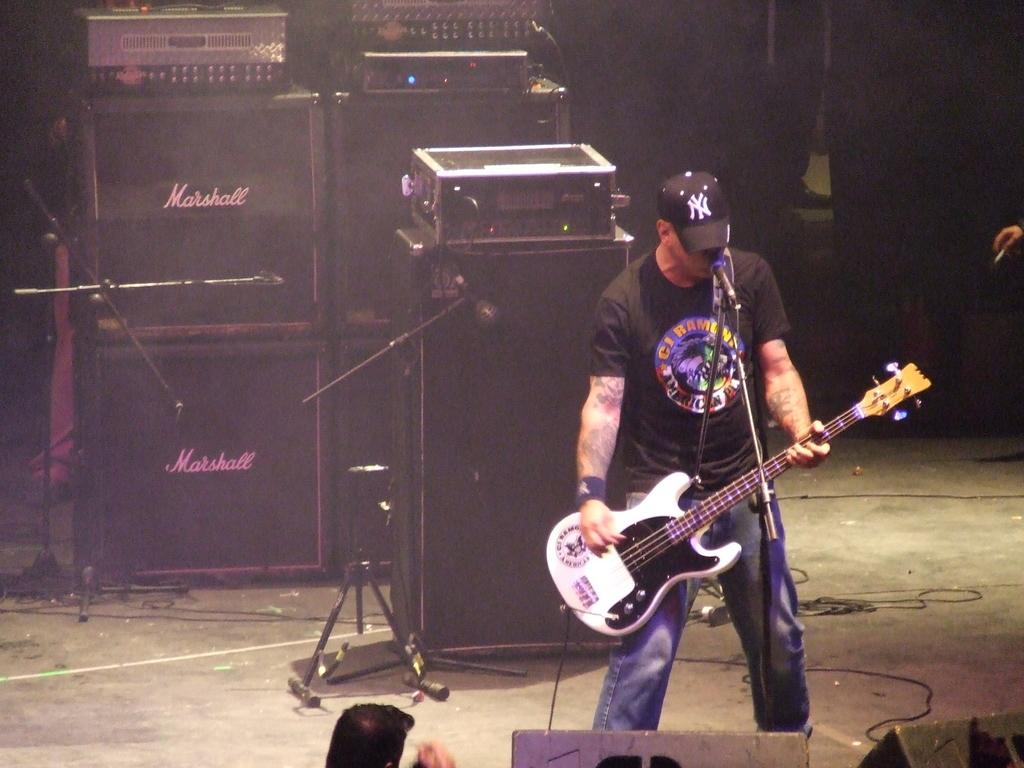What is the person in the image holding? The person is holding a guitar. What object is present in the image that is typically used for amplifying sound? There are speakers visible in the image. What is the person likely to use along with the guitar? The person might use the microphone in the image for singing or speaking. What is the microphone attached to in the image? The microphone is attached to a microphone stand in the image. Where is the person's aunt sitting in the image? There is no mention of an aunt in the image, so we cannot determine where she might be sitting. 